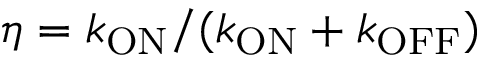Convert formula to latex. <formula><loc_0><loc_0><loc_500><loc_500>\eta = k _ { O N } / ( k _ { O N } + k _ { O F F } )</formula> 